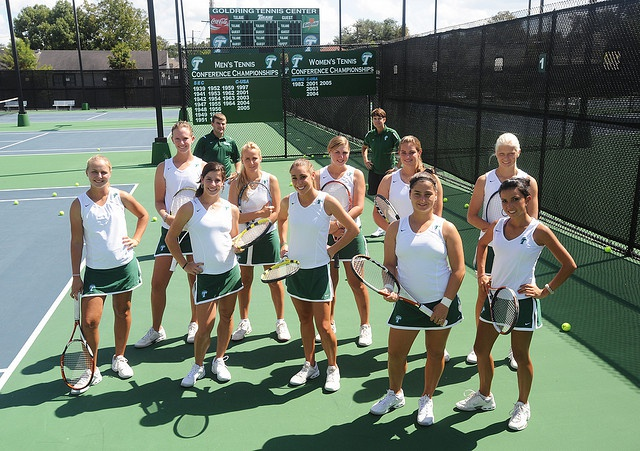Describe the objects in this image and their specific colors. I can see people in white, darkgray, maroon, and black tones, people in white, darkgray, and maroon tones, people in white, black, darkgray, and gray tones, people in white, darkgray, black, brown, and maroon tones, and people in white, maroon, black, and darkgray tones in this image. 